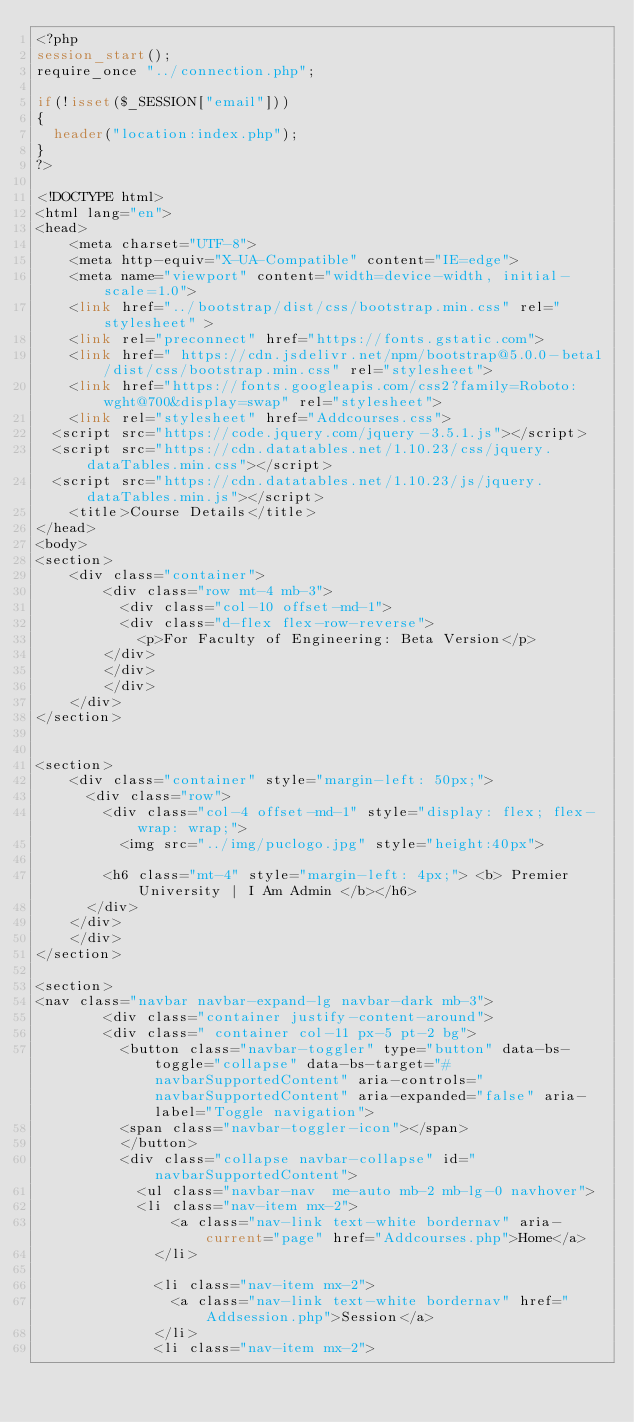Convert code to text. <code><loc_0><loc_0><loc_500><loc_500><_PHP_><?php
session_start();
require_once "../connection.php";

if(!isset($_SESSION["email"]))
{
  header("location:index.php");
}
?>

<!DOCTYPE html>
<html lang="en">
<head>
    <meta charset="UTF-8">
    <meta http-equiv="X-UA-Compatible" content="IE=edge">
    <meta name="viewport" content="width=device-width, initial-scale=1.0">
    <link href="../bootstrap/dist/css/bootstrap.min.css" rel="stylesheet" >
    <link rel="preconnect" href="https://fonts.gstatic.com">
    <link href=" https://cdn.jsdelivr.net/npm/bootstrap@5.0.0-beta1/dist/css/bootstrap.min.css" rel="stylesheet">
    <link href="https://fonts.googleapis.com/css2?family=Roboto:wght@700&display=swap" rel="stylesheet">
    <link rel="stylesheet" href="Addcourses.css">
  <script src="https://code.jquery.com/jquery-3.5.1.js"></script>
  <script src="https://cdn.datatables.net/1.10.23/css/jquery.dataTables.min.css"></script>
  <script src="https://cdn.datatables.net/1.10.23/js/jquery.dataTables.min.js"></script>
    <title>Course Details</title>
</head>
<body>
<section>
    <div class="container">
        <div class="row mt-4 mb-3">
          <div class="col-10 offset-md-1">
          <div class="d-flex flex-row-reverse">
            <p>For Faculty of Engineering: Beta Version</p>
        </div>
        </div>
        </div>
    </div>
</section>


<section>
    <div class="container" style="margin-left: 50px;">
      <div class="row">
        <div class="col-4 offset-md-1" style="display: flex; flex-wrap: wrap;">
          <img src="../img/puclogo.jpg" style="height:40px">
          
        <h6 class="mt-4" style="margin-left: 4px;"> <b> Premier University | I Am Admin </b></h6>
      </div>
    </div>
    </div>
</section>

<section>
<nav class="navbar navbar-expand-lg navbar-dark mb-3">
        <div class="container justify-content-around">
        <div class=" container col-11 px-5 pt-2 bg">
          <button class="navbar-toggler" type="button" data-bs-toggle="collapse" data-bs-target="#navbarSupportedContent" aria-controls="navbarSupportedContent" aria-expanded="false" aria-label="Toggle navigation">
          <span class="navbar-toggler-icon"></span>
          </button>
          <div class="collapse navbar-collapse" id="navbarSupportedContent">
            <ul class="navbar-nav  me-auto mb-2 mb-lg-0 navhover">
            <li class="nav-item mx-2">
                <a class="nav-link text-white bordernav" aria-current="page" href="Addcourses.php">Home</a>
              </li>
            
              <li class="nav-item mx-2">
                <a class="nav-link text-white bordernav" href="Addsession.php">Session</a>
              </li>
              <li class="nav-item mx-2"></code> 